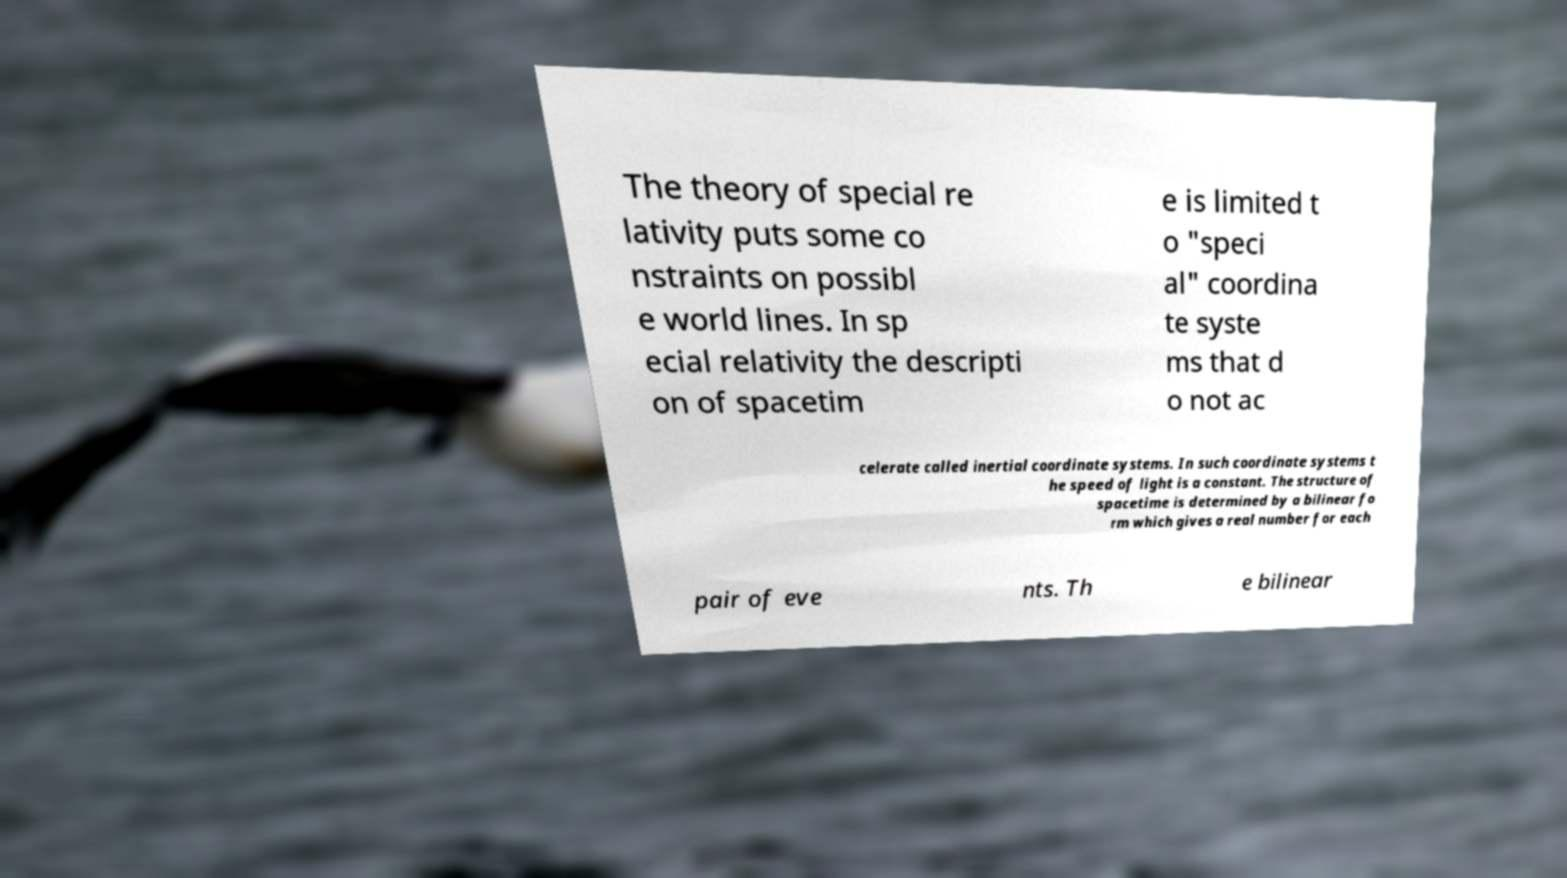Could you assist in decoding the text presented in this image and type it out clearly? The theory of special re lativity puts some co nstraints on possibl e world lines. In sp ecial relativity the descripti on of spacetim e is limited t o "speci al" coordina te syste ms that d o not ac celerate called inertial coordinate systems. In such coordinate systems t he speed of light is a constant. The structure of spacetime is determined by a bilinear fo rm which gives a real number for each pair of eve nts. Th e bilinear 